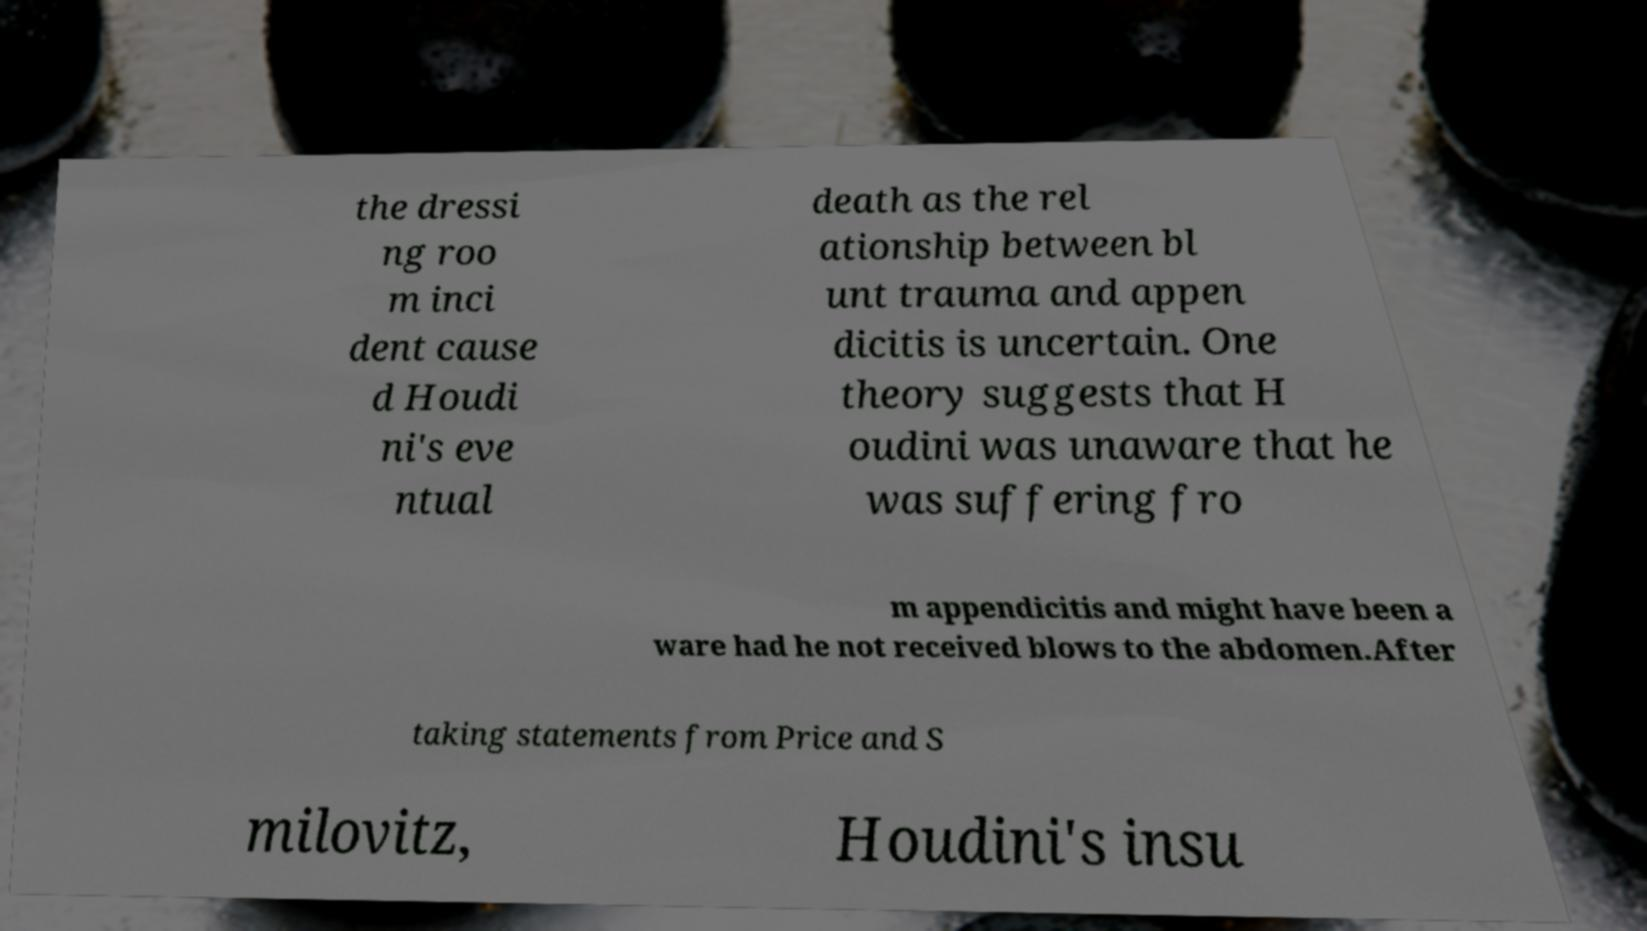Can you read and provide the text displayed in the image?This photo seems to have some interesting text. Can you extract and type it out for me? the dressi ng roo m inci dent cause d Houdi ni's eve ntual death as the rel ationship between bl unt trauma and appen dicitis is uncertain. One theory suggests that H oudini was unaware that he was suffering fro m appendicitis and might have been a ware had he not received blows to the abdomen.After taking statements from Price and S milovitz, Houdini's insu 